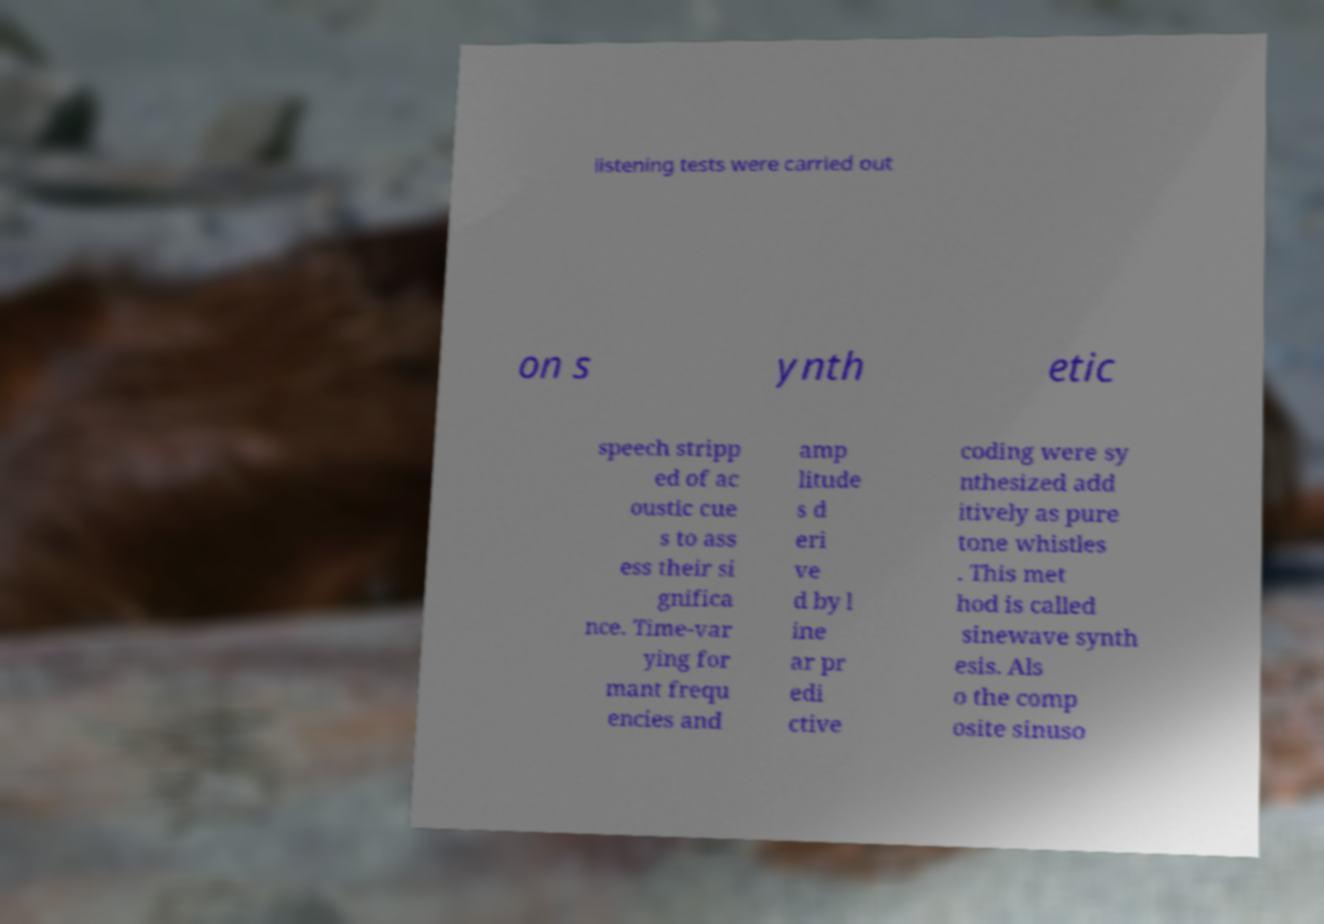Could you assist in decoding the text presented in this image and type it out clearly? listening tests were carried out on s ynth etic speech stripp ed of ac oustic cue s to ass ess their si gnifica nce. Time-var ying for mant frequ encies and amp litude s d eri ve d by l ine ar pr edi ctive coding were sy nthesized add itively as pure tone whistles . This met hod is called sinewave synth esis. Als o the comp osite sinuso 